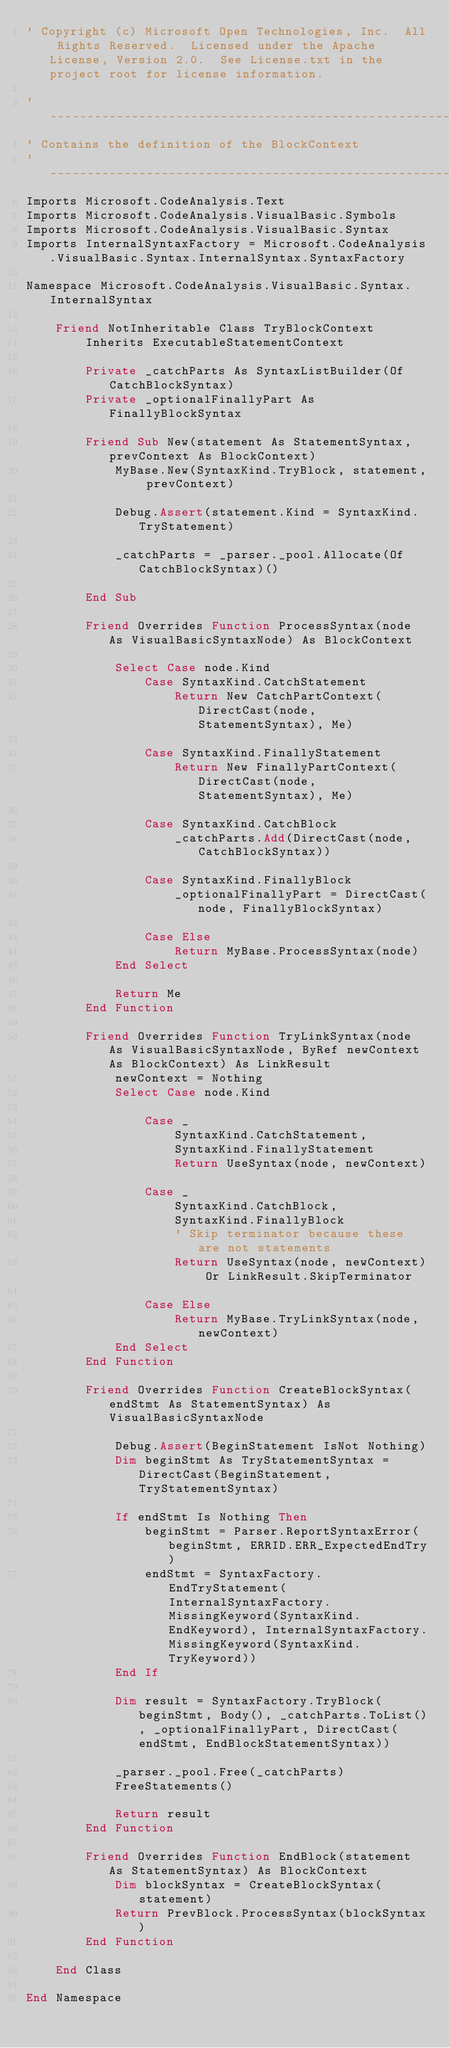Convert code to text. <code><loc_0><loc_0><loc_500><loc_500><_VisualBasic_>' Copyright (c) Microsoft Open Technologies, Inc.  All Rights Reserved.  Licensed under the Apache License, Version 2.0.  See License.txt in the project root for license information.

'-----------------------------------------------------------------------------
' Contains the definition of the BlockContext
'-----------------------------------------------------------------------------
Imports Microsoft.CodeAnalysis.Text
Imports Microsoft.CodeAnalysis.VisualBasic.Symbols
Imports Microsoft.CodeAnalysis.VisualBasic.Syntax
Imports InternalSyntaxFactory = Microsoft.CodeAnalysis.VisualBasic.Syntax.InternalSyntax.SyntaxFactory

Namespace Microsoft.CodeAnalysis.VisualBasic.Syntax.InternalSyntax

    Friend NotInheritable Class TryBlockContext
        Inherits ExecutableStatementContext

        Private _catchParts As SyntaxListBuilder(Of CatchBlockSyntax)
        Private _optionalFinallyPart As FinallyBlockSyntax

        Friend Sub New(statement As StatementSyntax, prevContext As BlockContext)
            MyBase.New(SyntaxKind.TryBlock, statement, prevContext)

            Debug.Assert(statement.Kind = SyntaxKind.TryStatement)

            _catchParts = _parser._pool.Allocate(Of CatchBlockSyntax)()

        End Sub

        Friend Overrides Function ProcessSyntax(node As VisualBasicSyntaxNode) As BlockContext

            Select Case node.Kind
                Case SyntaxKind.CatchStatement
                    Return New CatchPartContext(DirectCast(node, StatementSyntax), Me)

                Case SyntaxKind.FinallyStatement
                    Return New FinallyPartContext(DirectCast(node, StatementSyntax), Me)

                Case SyntaxKind.CatchBlock
                    _catchParts.Add(DirectCast(node, CatchBlockSyntax))

                Case SyntaxKind.FinallyBlock
                    _optionalFinallyPart = DirectCast(node, FinallyBlockSyntax)

                Case Else
                    Return MyBase.ProcessSyntax(node)
            End Select

            Return Me
        End Function

        Friend Overrides Function TryLinkSyntax(node As VisualBasicSyntaxNode, ByRef newContext As BlockContext) As LinkResult
            newContext = Nothing
            Select Case node.Kind

                Case _
                    SyntaxKind.CatchStatement,
                    SyntaxKind.FinallyStatement
                    Return UseSyntax(node, newContext)

                Case _
                    SyntaxKind.CatchBlock,
                    SyntaxKind.FinallyBlock
                    ' Skip terminator because these are not statements
                    Return UseSyntax(node, newContext) Or LinkResult.SkipTerminator

                Case Else
                    Return MyBase.TryLinkSyntax(node, newContext)
            End Select
        End Function

        Friend Overrides Function CreateBlockSyntax(endStmt As StatementSyntax) As VisualBasicSyntaxNode

            Debug.Assert(BeginStatement IsNot Nothing)
            Dim beginStmt As TryStatementSyntax = DirectCast(BeginStatement, TryStatementSyntax)

            If endStmt Is Nothing Then
                beginStmt = Parser.ReportSyntaxError(beginStmt, ERRID.ERR_ExpectedEndTry)
                endStmt = SyntaxFactory.EndTryStatement(InternalSyntaxFactory.MissingKeyword(SyntaxKind.EndKeyword), InternalSyntaxFactory.MissingKeyword(SyntaxKind.TryKeyword))
            End If

            Dim result = SyntaxFactory.TryBlock(beginStmt, Body(), _catchParts.ToList(), _optionalFinallyPart, DirectCast(endStmt, EndBlockStatementSyntax))

            _parser._pool.Free(_catchParts)
            FreeStatements()

            Return result
        End Function

        Friend Overrides Function EndBlock(statement As StatementSyntax) As BlockContext
            Dim blockSyntax = CreateBlockSyntax(statement)
            Return PrevBlock.ProcessSyntax(blockSyntax)
        End Function

    End Class

End Namespace</code> 